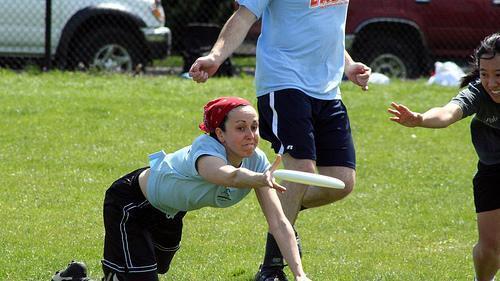How many people have knees on the ground?
Give a very brief answer. 1. 